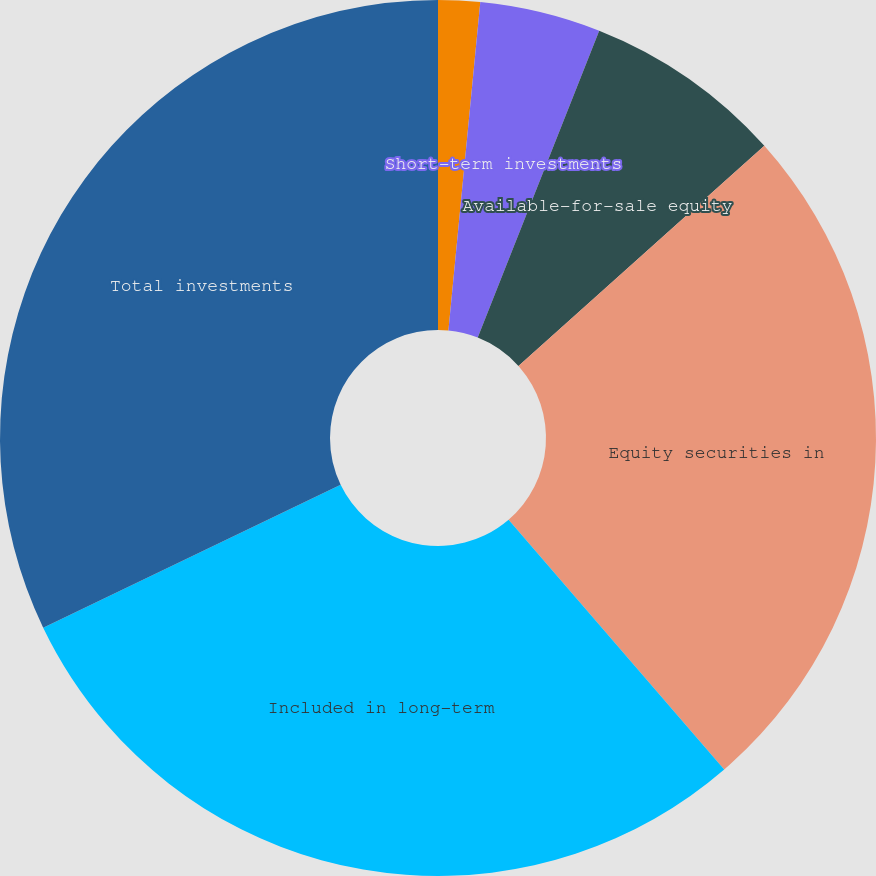Convert chart. <chart><loc_0><loc_0><loc_500><loc_500><pie_chart><fcel>Available-for-sale debt<fcel>Short-term investments<fcel>Available-for-sale equity<fcel>Equity securities in<fcel>Included in long-term<fcel>Total investments<nl><fcel>1.54%<fcel>4.46%<fcel>7.38%<fcel>25.29%<fcel>29.21%<fcel>32.13%<nl></chart> 